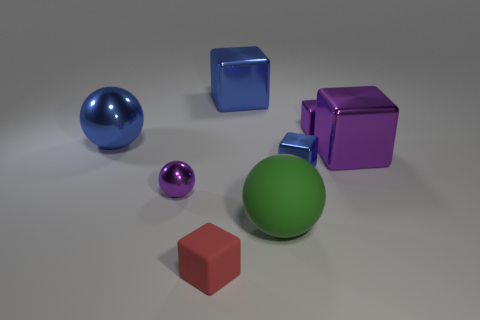Subtract all blue cubes. How many cubes are left? 3 Subtract all small purple metallic cubes. How many cubes are left? 4 Subtract all gray cubes. Subtract all blue cylinders. How many cubes are left? 5 Add 1 large blue metallic spheres. How many objects exist? 9 Subtract all balls. How many objects are left? 5 Add 1 big metallic cubes. How many big metallic cubes are left? 3 Add 1 blue shiny cylinders. How many blue shiny cylinders exist? 1 Subtract 0 brown balls. How many objects are left? 8 Subtract all balls. Subtract all large purple blocks. How many objects are left? 4 